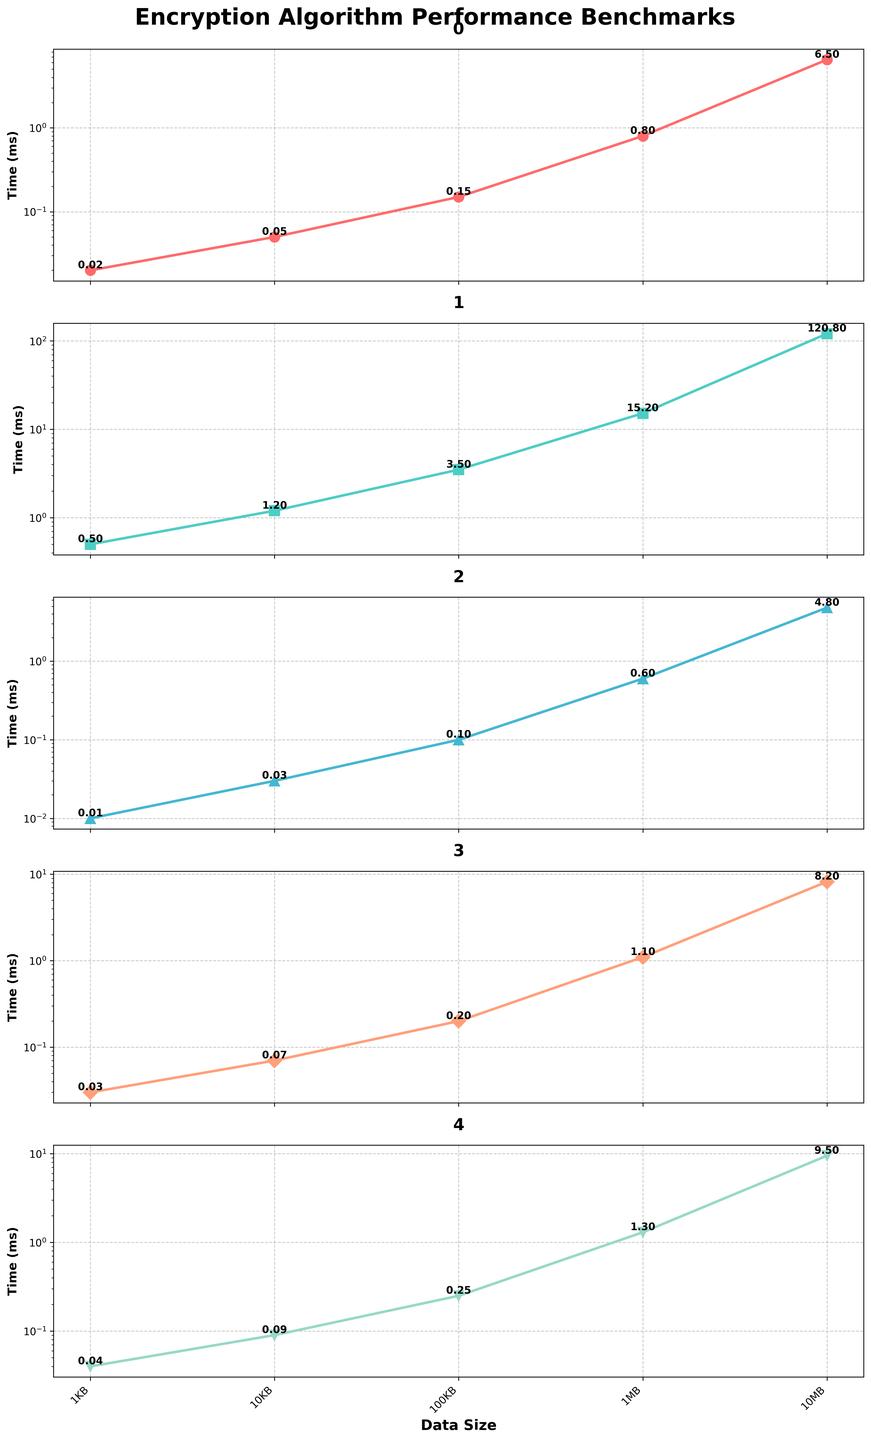Which encryption algorithm has the title colored red? The title of the AES-256 plot is colored red. By inspecting the colors used in the plot, the one with the red title is AES-256.
Answer: AES-256 What's the range of data sizes used in the benchmarks? The x-axis labels show the range of data sizes used in the benchmarks, which includes 1KB, 10KB, 100KB, 1MB, and 10MB.
Answer: 1KB to 10MB What is the encryption time for RSA-4096 with 10KB data? By looking at the RSA-4096 plot for the 10KB data point, you can see the encryption time is indicated as 1.2 ms.
Answer: 1.2 ms Which algorithm performs the fastest for 1MB data? Comparing the 1MB data point across all plots, you can see that ChaCha20 has the lowest encryption time at 0.6 ms.
Answer: ChaCha20 How does Blowfish's performance for 10MB data compare to AES-256? For the 10MB data point, Blowfish takes 8.2 ms and AES-256 takes 6.5 ms. Blowfish is slower by 1.7 ms.
Answer: Blowfish is slower Rank the algorithms from fastest to slowest for 100KB data size. By inspecting the 100KB data point in the subplots, ChaCha20 is the fastest (0.1 ms), followed by AES-256 (0.15 ms), Blowfish (0.2 ms), Twofish (0.25 ms), and RSA-4096 (3.5 ms).
Answer: ChaCha20, AES-256, Blowfish, Twofish, RSA-4096 What is the steepest increase in encryption time observed across the data sizes for any algorithm? The steepest increase can be found in the RSA-4096 plot, particularly from 1MB (15.2 ms) to 10MB (120.8 ms), which is an increase of 105.6 ms.
Answer: RSA-4096 from 1MB to 10MB Compare the performance of Twofish and Blowfish for 1KB and 10MB data sizes. For the 1KB data size, Blowfish is at 0.03 ms and Twofish at 0.04 ms (Blowfish is faster by 0.01 ms); for 10MB, Blowfish is at 8.2 ms and Twofish at 9.5 ms (Blowfish is faster by 1.3 ms).
Answer: Blowfish is faster for both 1KB and 10MB Which algorithm shows the smallest increase in encryption time from 1KB to 10KB? In the plots, the increase in encryption time from 1KB to 10KB for ChaCha20 is 0.02 ms (0.03 - 0.01), which is the smallest increase among all algorithms.
Answer: ChaCha20 How does the logarithmic scale on the y-axis help in interpreting the data? The logarithmic scale on the y-axis allows us to see the differences in encryption times for various data sizes more clearly, especially as the encryption times vary widely from 0.01 ms to 120.8 ms.
Answer: It clarifies differences in encryption times 